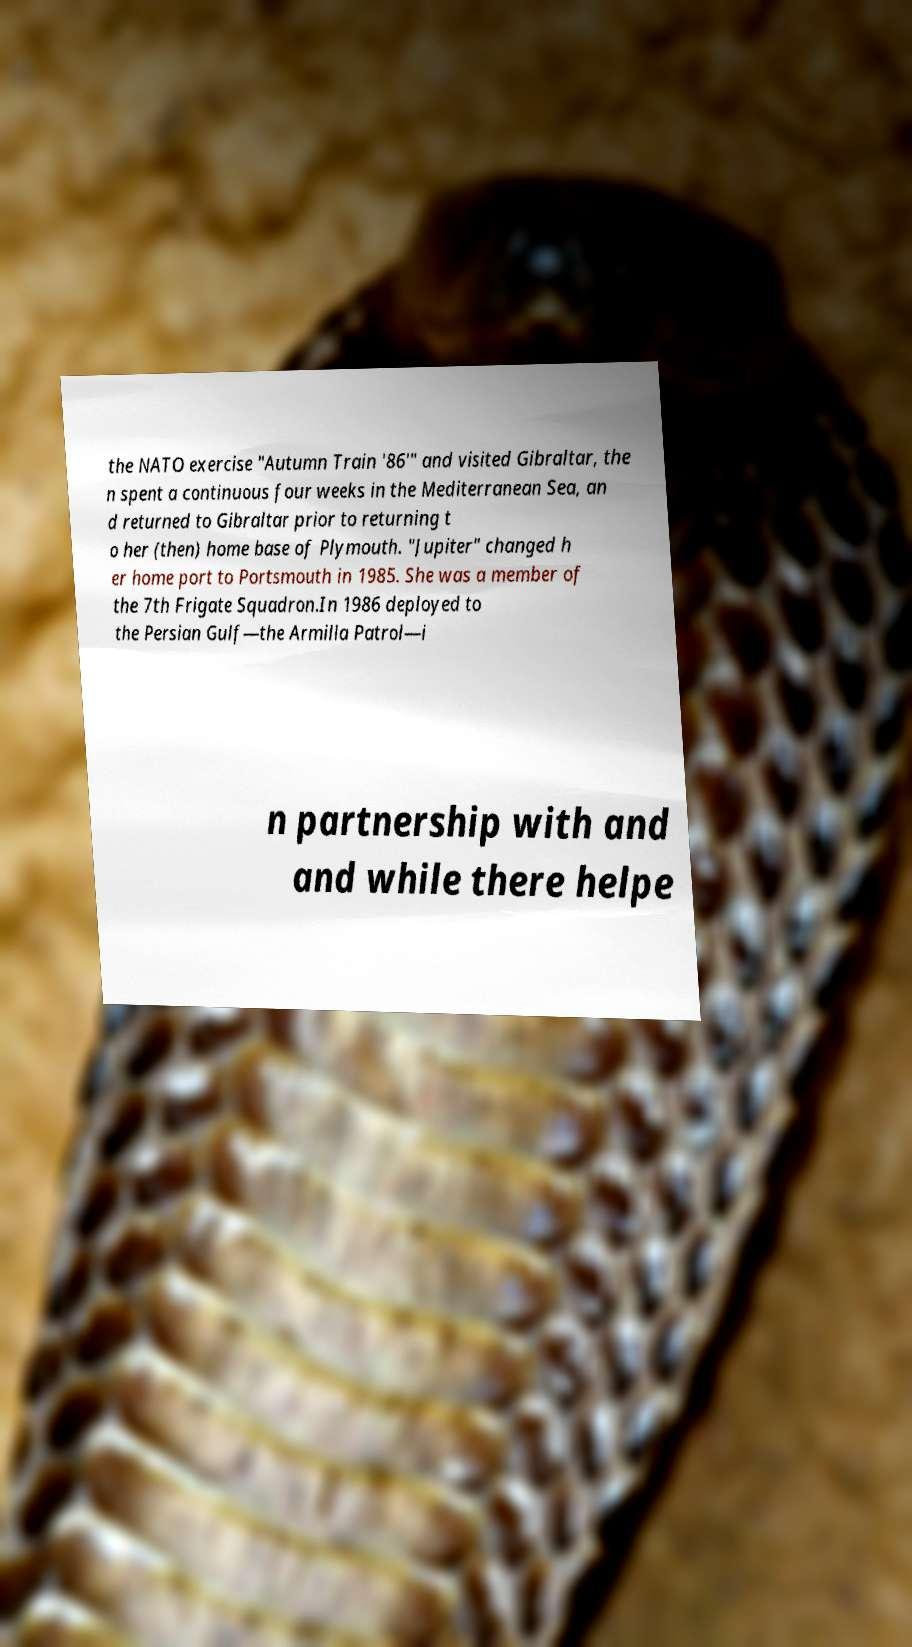Please identify and transcribe the text found in this image. the NATO exercise "Autumn Train '86'" and visited Gibraltar, the n spent a continuous four weeks in the Mediterranean Sea, an d returned to Gibraltar prior to returning t o her (then) home base of Plymouth. "Jupiter" changed h er home port to Portsmouth in 1985. She was a member of the 7th Frigate Squadron.In 1986 deployed to the Persian Gulf—the Armilla Patrol—i n partnership with and and while there helpe 